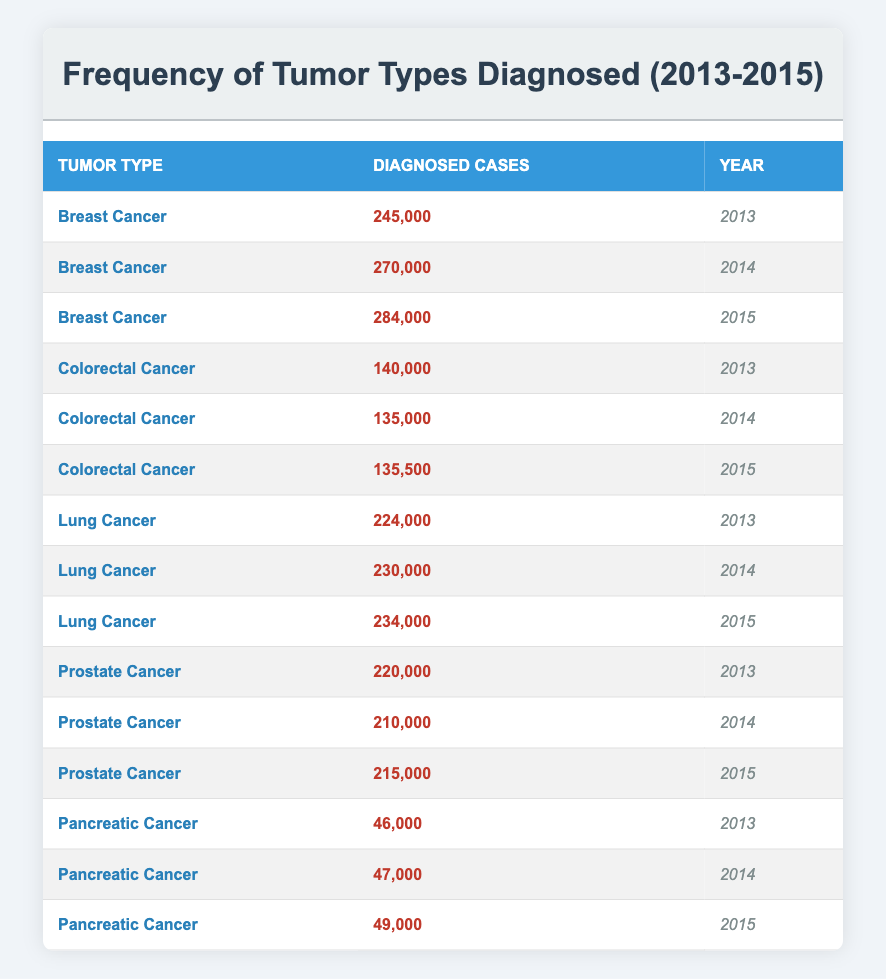What is the total number of breast cancer cases diagnosed from 2013 to 2015? There are three years of data for breast cancer: 245,000 (2013), 270,000 (2014), and 284,000 (2015). Adding these figures together gives: 245,000 + 270,000 + 284,000 = 799,000.
Answer: 799,000 Which year had the highest number of diagnosed lung cancer cases? Looking at the data for lung cancer, the diagnosed cases are: 224,000 (2013), 230,000 (2014), and 234,000 (2015). The highest value is 234,000 in 2015.
Answer: 2015 Is the number of diagnosed colorectal cancer cases in 2014 lower than in 2013? The data shows 140,000 cases in 2013 and 135,000 in 2014. Since 135,000 is less than 140,000, we can conclude that it is, in fact, lower.
Answer: Yes What is the difference in the number of diagnosed cases for prostate cancer between 2015 and 2014? For prostate cancer, the number of diagnosed cases in 2014 is 210,000 and in 2015 is 215,000. The difference is calculated as: 215,000 - 210,000 = 5,000.
Answer: 5,000 Which type of cancer had the least number of diagnosed cases in 2013? Reviewing the data for the year 2013, the diagnosed cases are: Breast Cancer (245,000), Colorectal Cancer (140,000), Lung Cancer (224,000), Prostate Cancer (220,000), and Pancreatic Cancer (46,000). The least is 46,000 for Pancreatic Cancer.
Answer: Pancreatic Cancer 